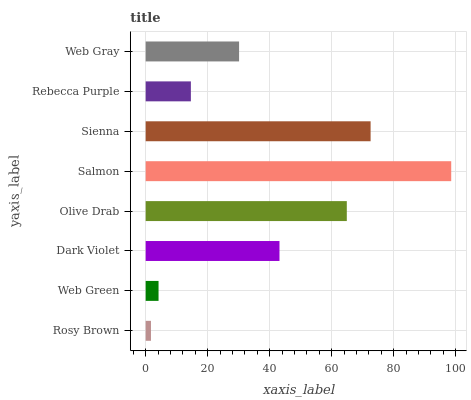Is Rosy Brown the minimum?
Answer yes or no. Yes. Is Salmon the maximum?
Answer yes or no. Yes. Is Web Green the minimum?
Answer yes or no. No. Is Web Green the maximum?
Answer yes or no. No. Is Web Green greater than Rosy Brown?
Answer yes or no. Yes. Is Rosy Brown less than Web Green?
Answer yes or no. Yes. Is Rosy Brown greater than Web Green?
Answer yes or no. No. Is Web Green less than Rosy Brown?
Answer yes or no. No. Is Dark Violet the high median?
Answer yes or no. Yes. Is Web Gray the low median?
Answer yes or no. Yes. Is Web Gray the high median?
Answer yes or no. No. Is Web Green the low median?
Answer yes or no. No. 